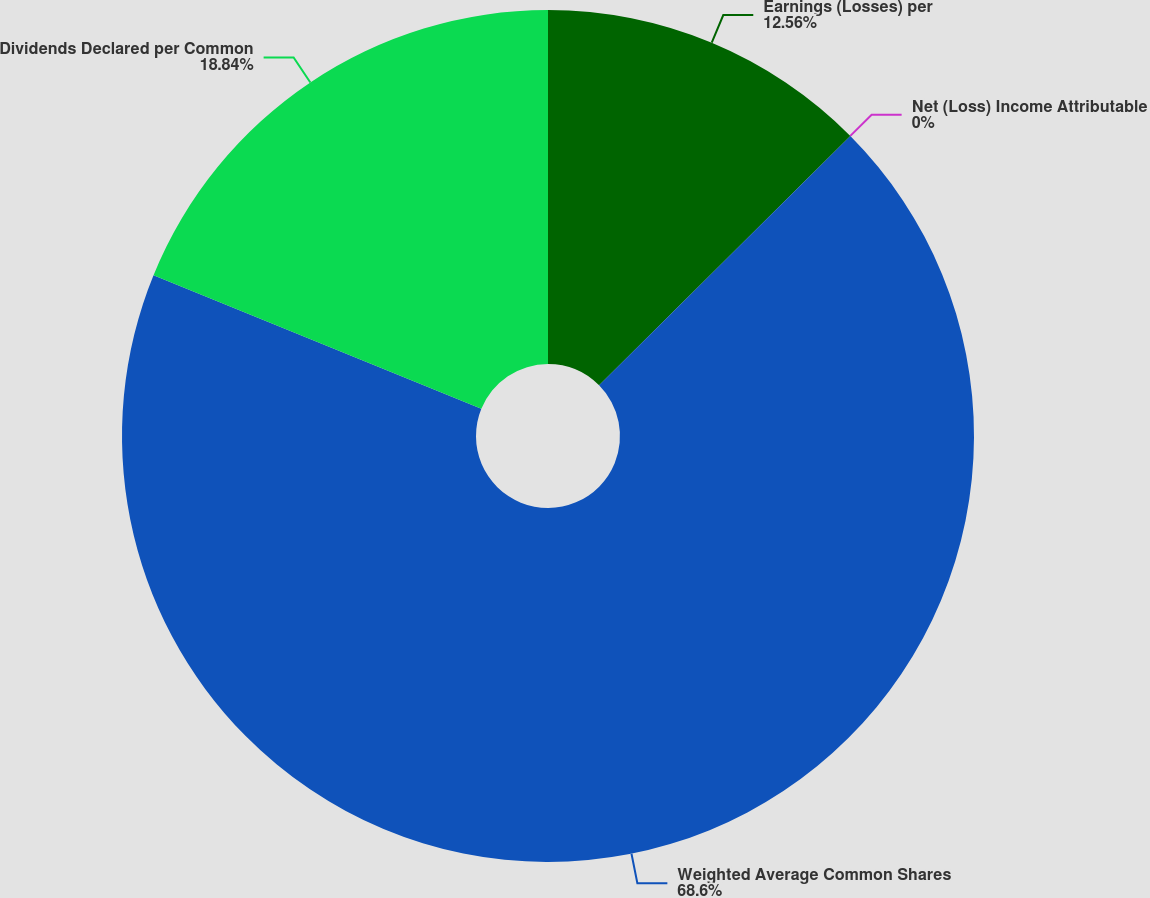Convert chart to OTSL. <chart><loc_0><loc_0><loc_500><loc_500><pie_chart><fcel>Earnings (Losses) per<fcel>Net (Loss) Income Attributable<fcel>Weighted Average Common Shares<fcel>Dividends Declared per Common<nl><fcel>12.56%<fcel>0.0%<fcel>68.61%<fcel>18.84%<nl></chart> 